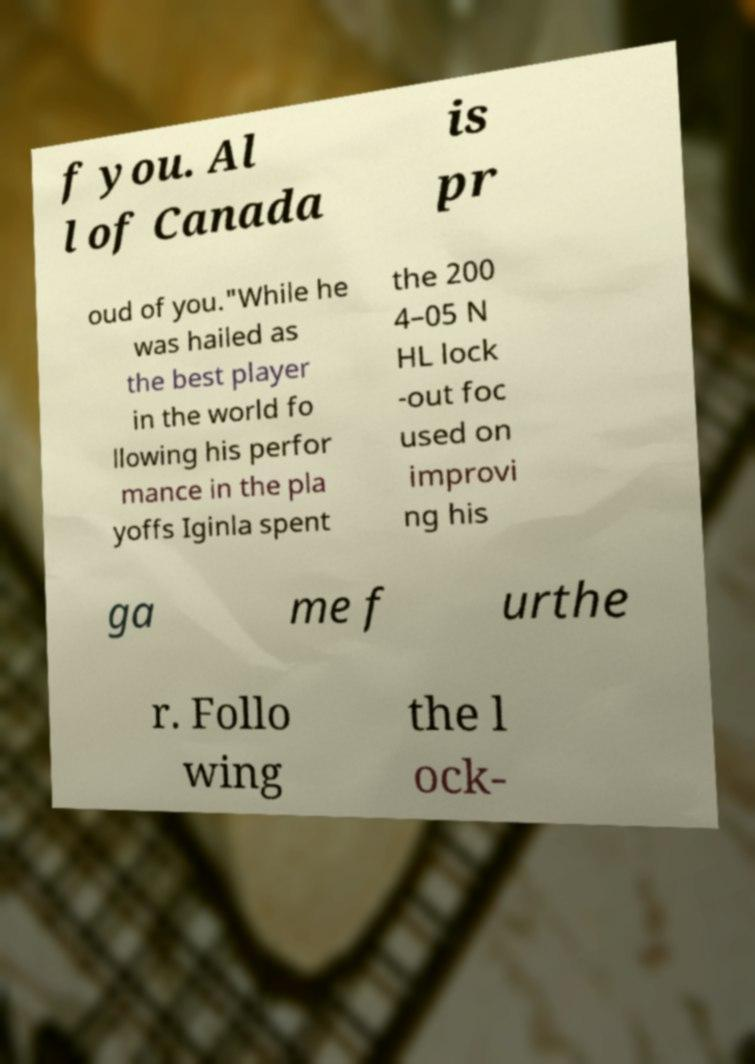Please identify and transcribe the text found in this image. f you. Al l of Canada is pr oud of you."While he was hailed as the best player in the world fo llowing his perfor mance in the pla yoffs Iginla spent the 200 4–05 N HL lock -out foc used on improvi ng his ga me f urthe r. Follo wing the l ock- 